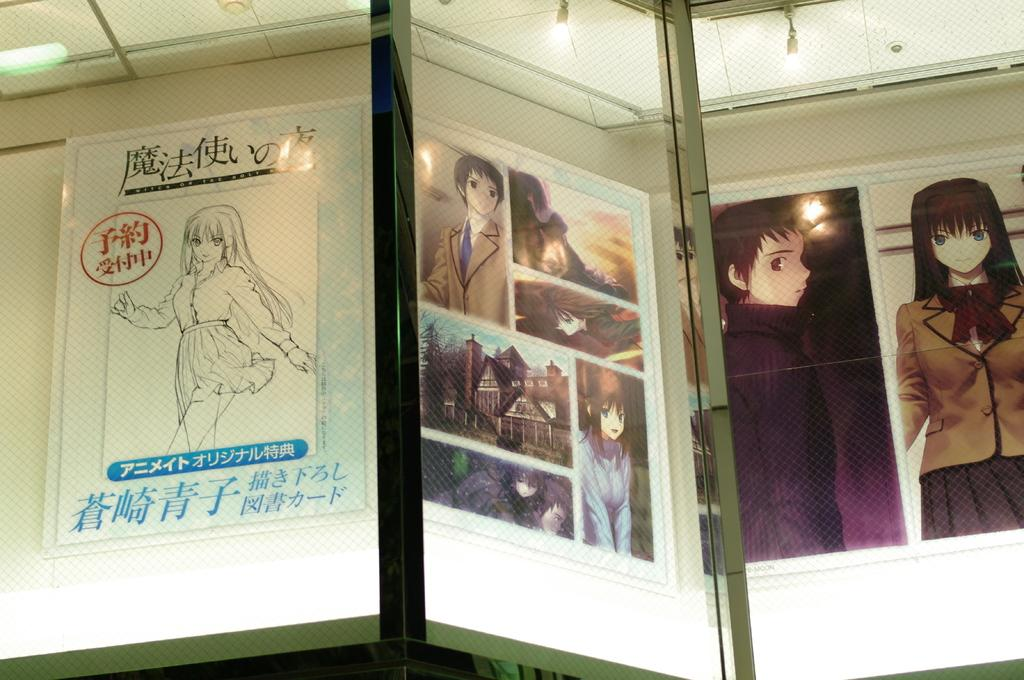Where was the image taken? The image was taken indoors. What can be seen on the wall in the image? There are picture frames and posters on the wall in the image. What type of lighting is present in the image? There are lights in the image. What objects can be seen in the image that might be used for drinking? There are glasses in the image. What type of potato dish is being prepared on the floor in the image? There is no potato dish or any cooking activity present in the image; it only shows a wall with picture frames and posters, lights, and glasses. 